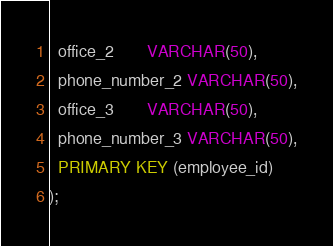<code> <loc_0><loc_0><loc_500><loc_500><_SQL_>  office_2       VARCHAR(50),
  phone_number_2 VARCHAR(50),
  office_3       VARCHAR(50),
  phone_number_3 VARCHAR(50),
  PRIMARY KEY (employee_id)
);
</code> 